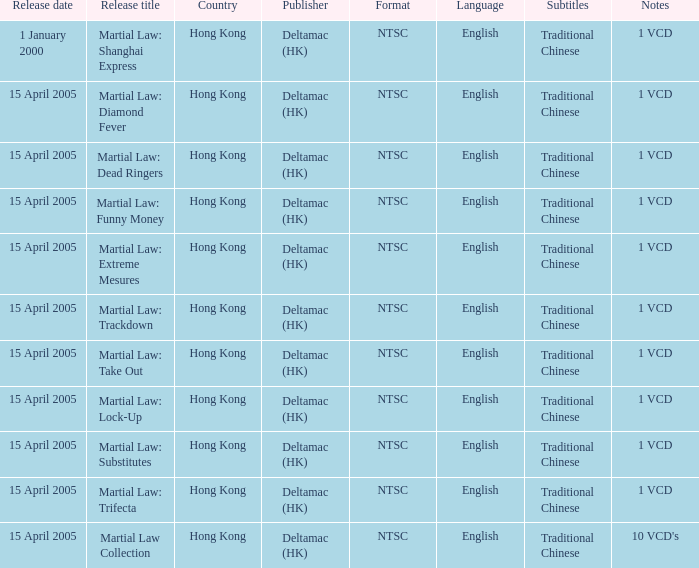Who was the publisher of Martial Law: Dead Ringers? Deltamac (HK). 